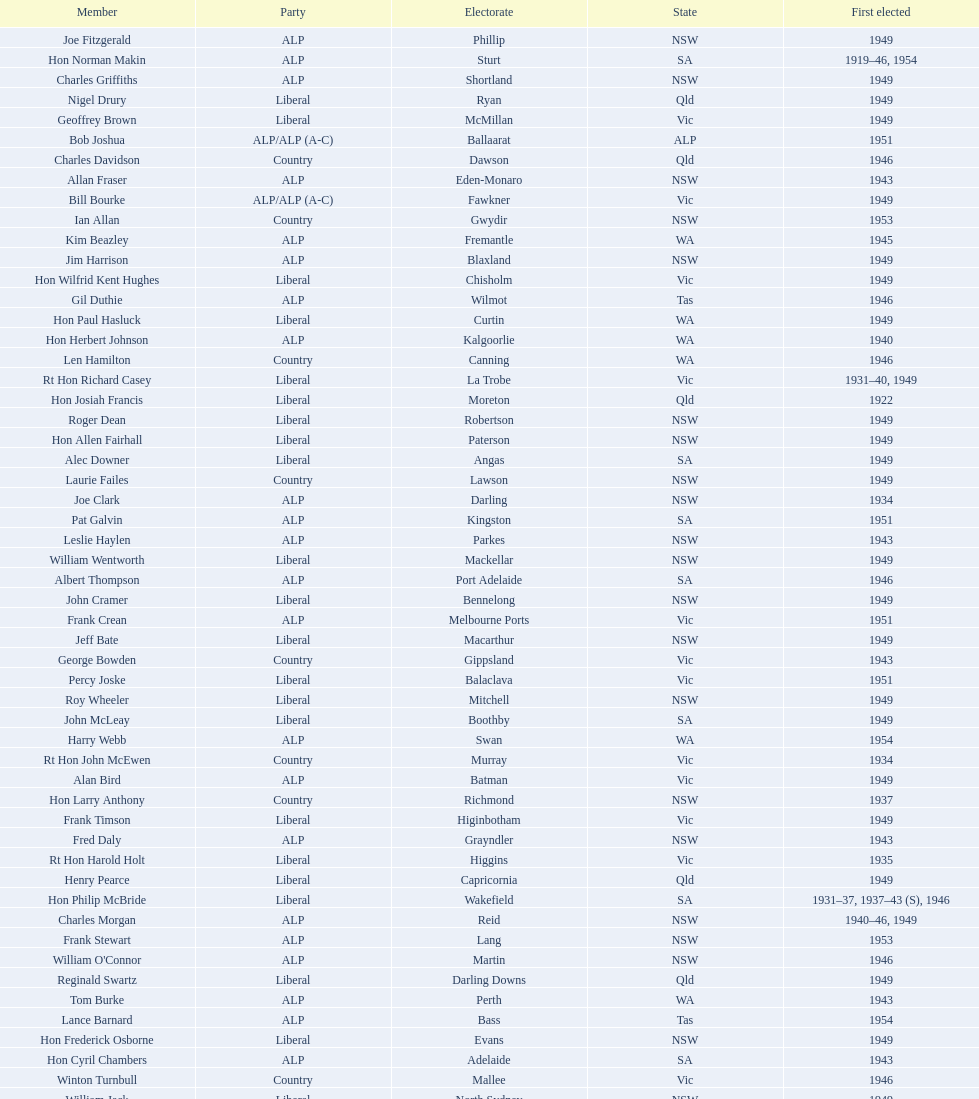Previous to tom andrews who was elected? Gordon Anderson. 